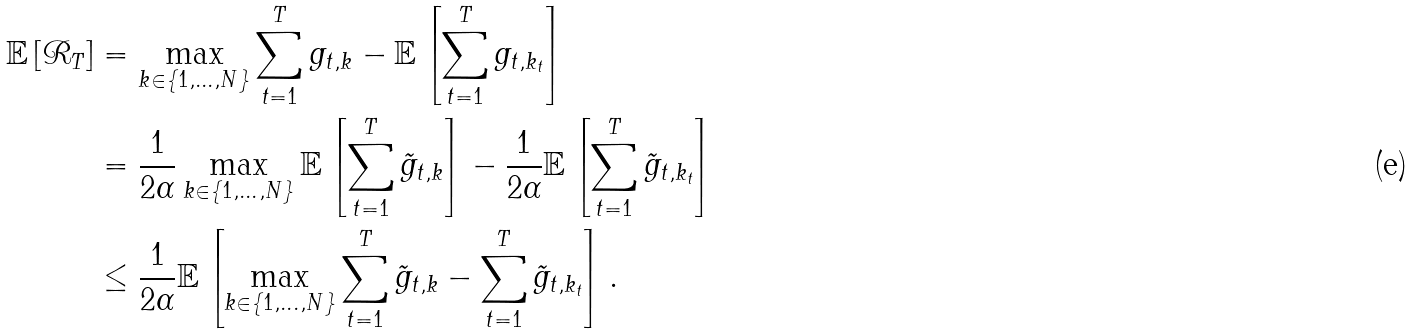<formula> <loc_0><loc_0><loc_500><loc_500>\mathbb { E } \left [ \mathcal { R } _ { T } \right ] & = \max _ { k \in \{ 1 , \dots , N \} } \sum _ { t = 1 } ^ { T } g _ { t , k } - \mathbb { E } \left [ \sum _ { t = 1 } ^ { T } g _ { t , k _ { t } } \right ] \\ & = \frac { 1 } { 2 \alpha } \max _ { k \in \{ 1 , \dots , N \} } \mathbb { E } \left [ \sum _ { t = 1 } ^ { T } \tilde { g } _ { t , k } \right ] - \frac { 1 } { 2 \alpha } \mathbb { E } \left [ \sum _ { t = 1 } ^ { T } \tilde { g } _ { t , k _ { t } } \right ] \\ & \leq \frac { 1 } { 2 \alpha } \mathbb { E } \left [ \max _ { k \in \{ 1 , \dots , N \} } \sum _ { t = 1 } ^ { T } \tilde { g } _ { t , k } - \sum _ { t = 1 } ^ { T } \tilde { g } _ { t , k _ { t } } \right ] .</formula> 